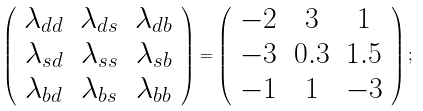Convert formula to latex. <formula><loc_0><loc_0><loc_500><loc_500>\left ( \begin{array} { c c c } \lambda _ { d d } & \lambda _ { d s } & \lambda _ { d b } \\ \lambda _ { s d } & \lambda _ { s s } & \lambda _ { s b } \\ \lambda _ { b d } & \lambda _ { b s } & \lambda _ { b b } \end{array} \right ) = \left ( \begin{array} { c c c } - 2 & 3 & 1 \\ - 3 & 0 . 3 & 1 . 5 \\ - 1 & 1 & - 3 \end{array} \right ) ;</formula> 